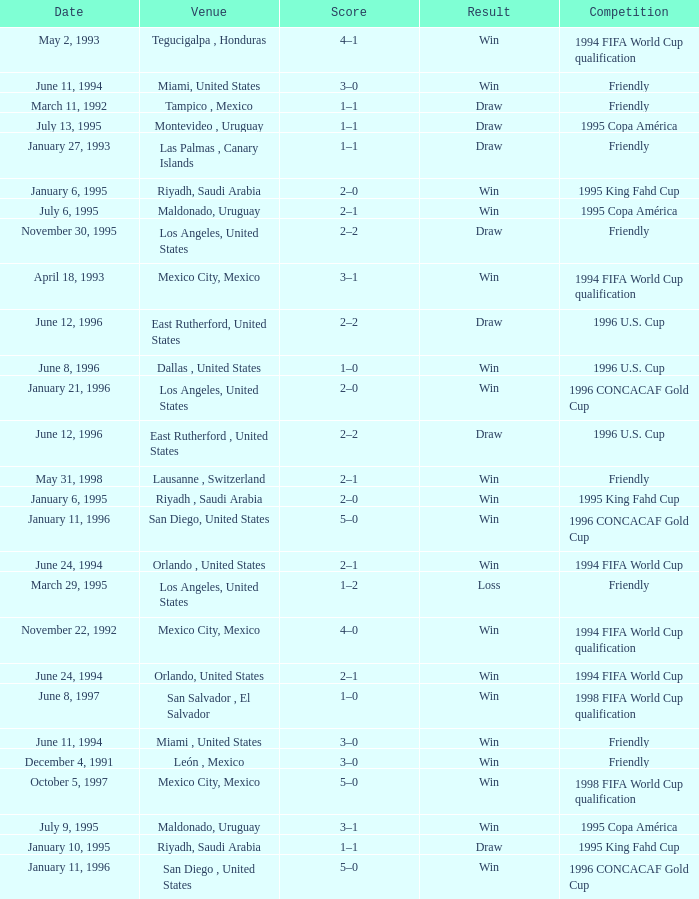What is Competition, when Date is "January 11, 1996", when Venue is "San Diego , United States"? 1996 CONCACAF Gold Cup, 1996 CONCACAF Gold Cup. 